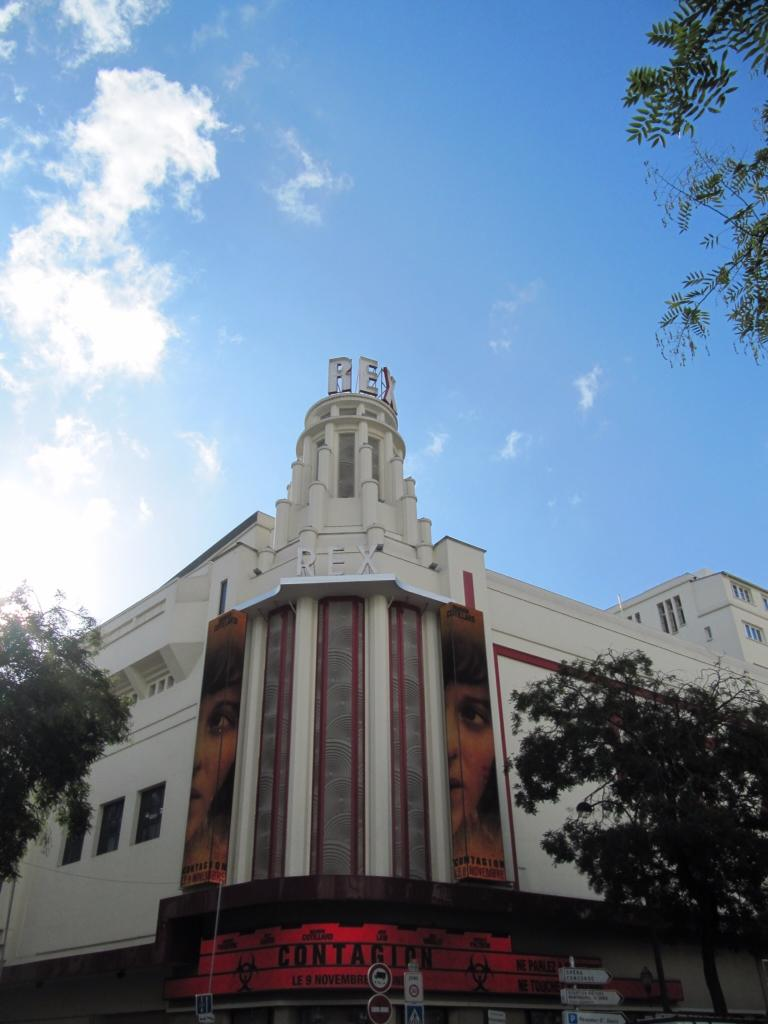<image>
Describe the image concisely. A movie theater advertising Contagion that starts november 9th. 